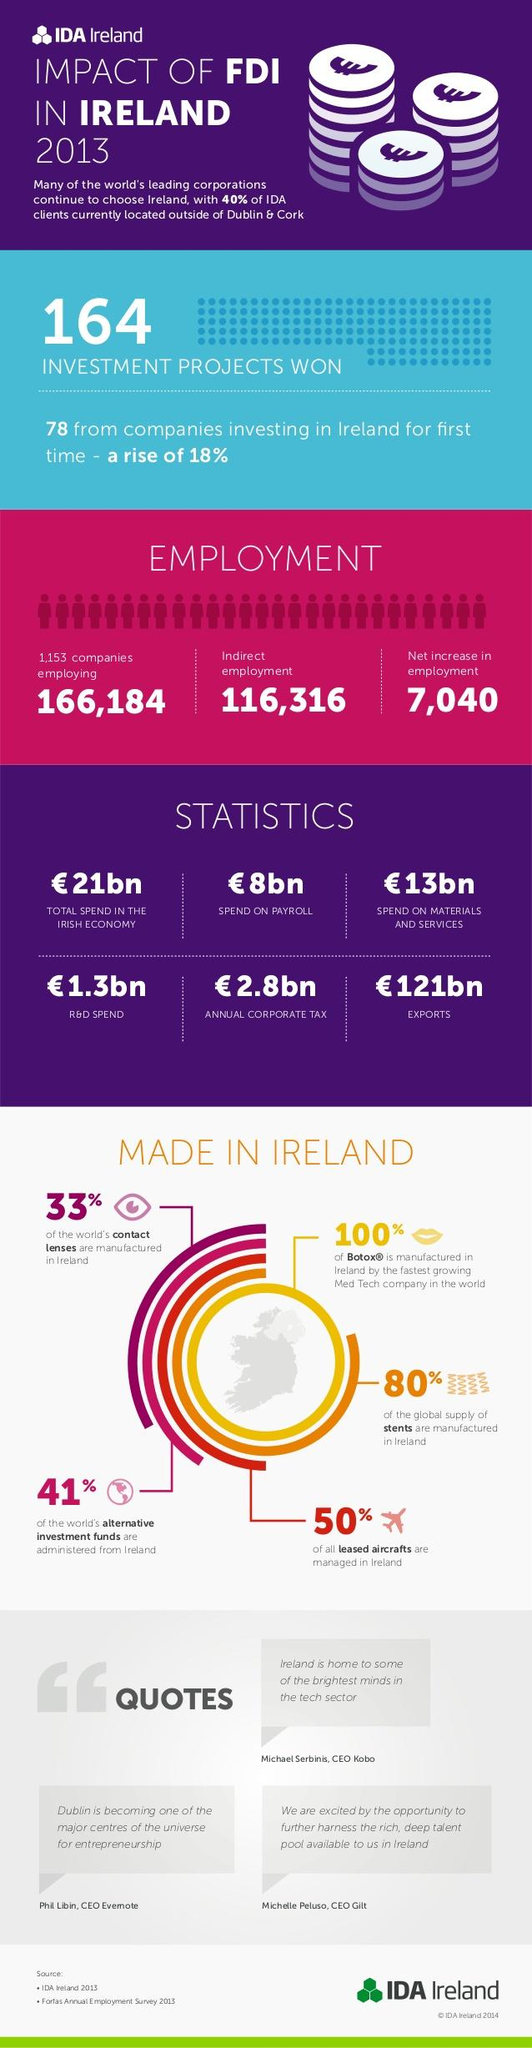Outline some significant characteristics in this image. In 2013, the export value of Ireland was 121 billion euros. The net increase in employment in Ireland due to the impact of FDI in 2013 was approximately 7,040. In 2013, the Republic of Ireland spent approximately 1.3 billion euros on research and development. 